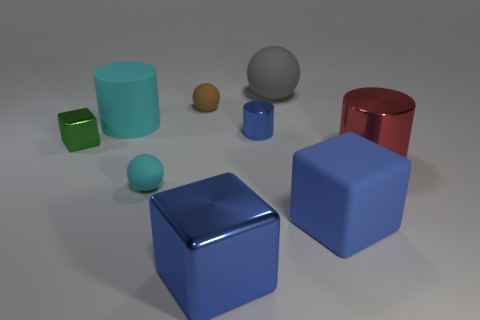Are there any large brown matte objects that have the same shape as the big red shiny object?
Keep it short and to the point. No. Is the shape of the big blue rubber object the same as the green thing?
Your answer should be very brief. Yes. What number of large things are gray spheres or gray shiny spheres?
Keep it short and to the point. 1. Are there more small cylinders than tiny things?
Your answer should be very brief. No. The cyan cylinder that is the same material as the big gray sphere is what size?
Make the answer very short. Large. There is a metal block that is to the right of the small brown matte ball; is it the same size as the block on the right side of the large ball?
Provide a succinct answer. Yes. What number of objects are either things that are behind the big blue matte cube or cyan rubber spheres?
Give a very brief answer. 7. Is the number of big red cylinders less than the number of cyan matte things?
Make the answer very short. Yes. There is a tiny rubber thing in front of the blue metallic object that is behind the large blue cube that is on the left side of the gray rubber object; what shape is it?
Provide a short and direct response. Sphere. The big object that is the same color as the big metallic block is what shape?
Keep it short and to the point. Cube. 